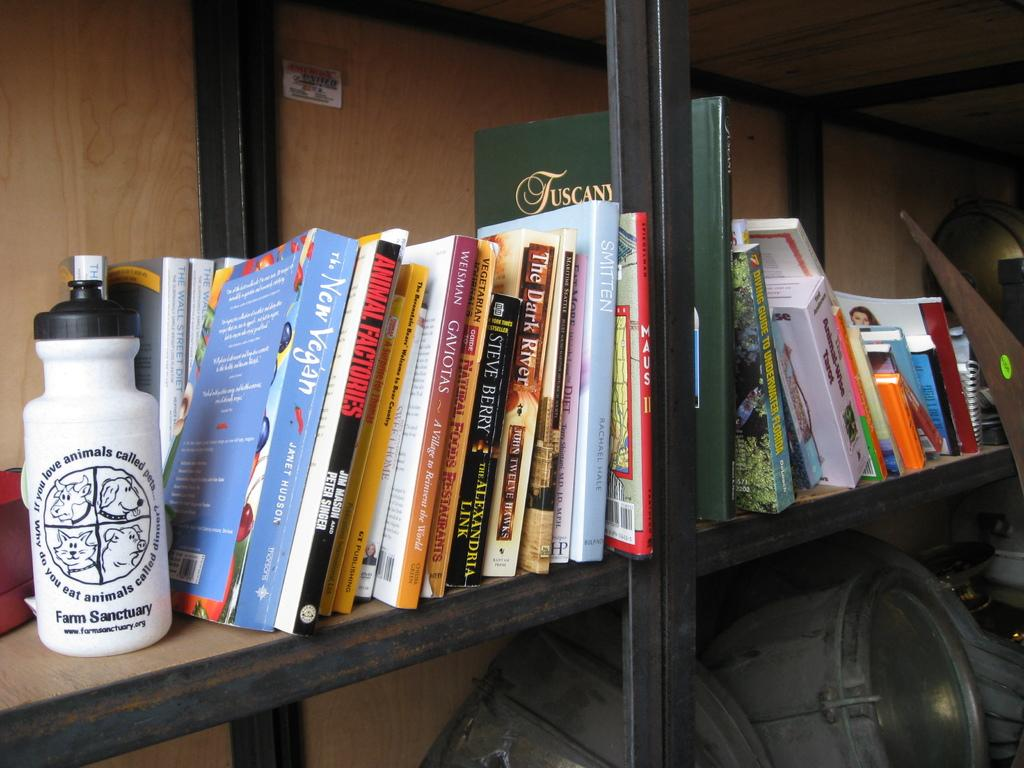<image>
Give a short and clear explanation of the subsequent image. Several books standing on a bookshelf next to a Farm Sanctuary water bottle. 